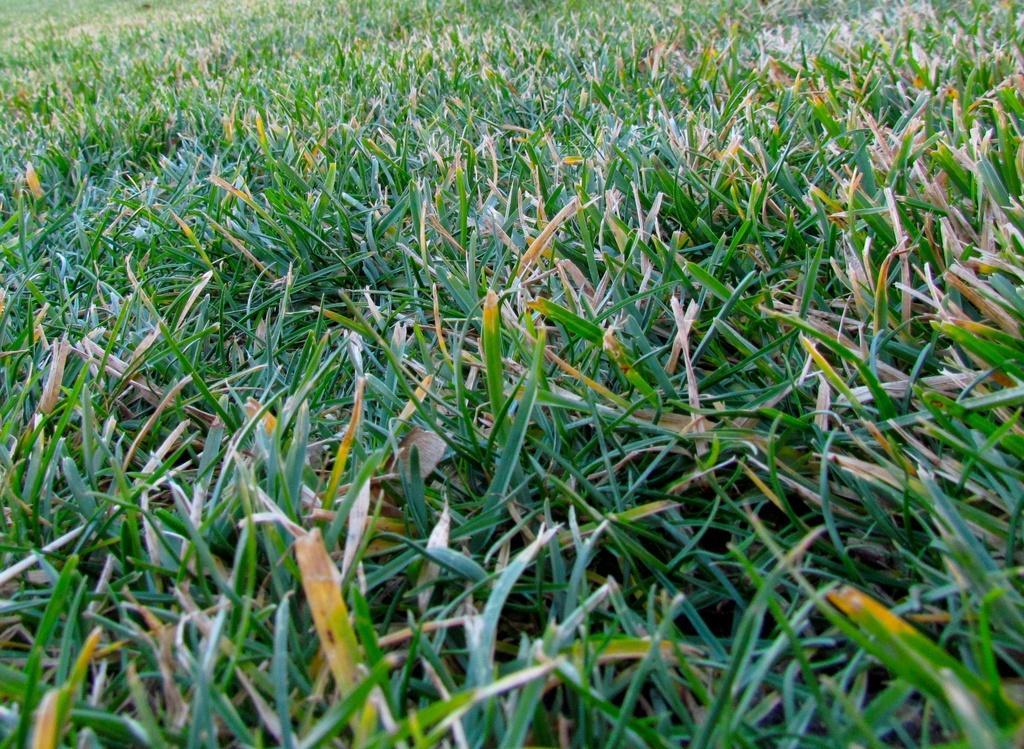Could you give a brief overview of what you see in this image? In this image, we can see green color grass. 